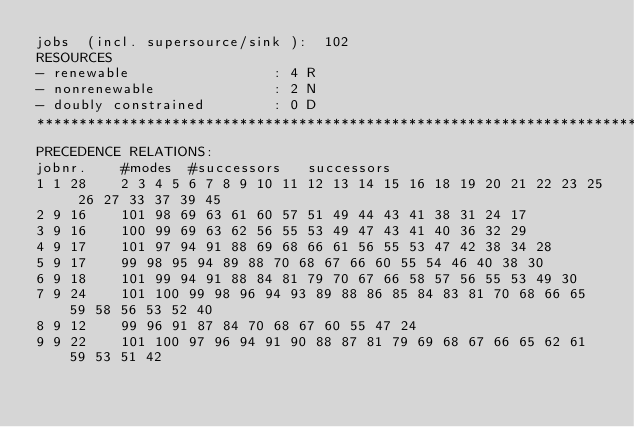<code> <loc_0><loc_0><loc_500><loc_500><_ObjectiveC_>jobs  (incl. supersource/sink ):	102
RESOURCES
- renewable                 : 4 R
- nonrenewable              : 2 N
- doubly constrained        : 0 D
************************************************************************
PRECEDENCE RELATIONS:
jobnr.    #modes  #successors   successors
1	1	28		2 3 4 5 6 7 8 9 10 11 12 13 14 15 16 18 19 20 21 22 23 25 26 27 33 37 39 45 
2	9	16		101 98 69 63 61 60 57 51 49 44 43 41 38 31 24 17 
3	9	16		100 99 69 63 62 56 55 53 49 47 43 41 40 36 32 29 
4	9	17		101 97 94 91 88 69 68 66 61 56 55 53 47 42 38 34 28 
5	9	17		99 98 95 94 89 88 70 68 67 66 60 55 54 46 40 38 30 
6	9	18		101 99 94 91 88 84 81 79 70 67 66 58 57 56 55 53 49 30 
7	9	24		101 100 99 98 96 94 93 89 88 86 85 84 83 81 70 68 66 65 59 58 56 53 52 40 
8	9	12		99 96 91 87 84 70 68 67 60 55 47 24 
9	9	22		101 100 97 96 94 91 90 88 87 81 79 69 68 67 66 65 62 61 59 53 51 42 </code> 